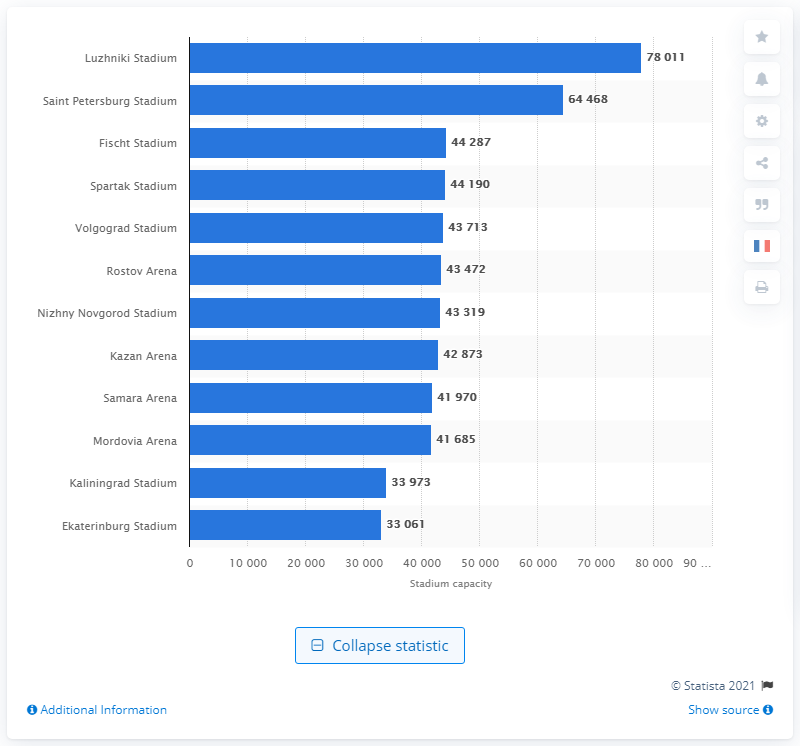Draw attention to some important aspects in this diagram. The 2018 FIFA World Cup was held in various venues across Russia, with the largest of them all being Luzhniki Stadium. 